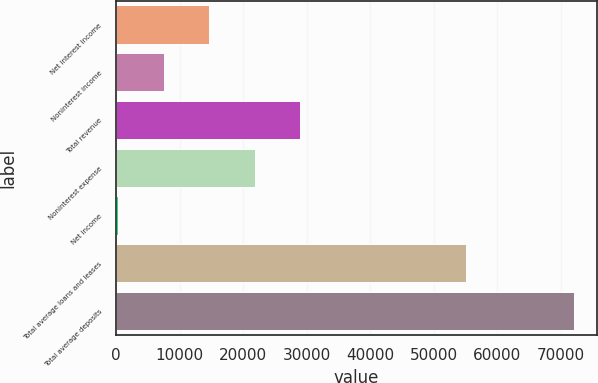Convert chart. <chart><loc_0><loc_0><loc_500><loc_500><bar_chart><fcel>Net interest income<fcel>Noninterest income<fcel>Total revenue<fcel>Noninterest expense<fcel>Net income<fcel>Total average loans and leases<fcel>Total average deposits<nl><fcel>14676.6<fcel>7510.8<fcel>29008.2<fcel>21842.4<fcel>345<fcel>55052<fcel>72003<nl></chart> 